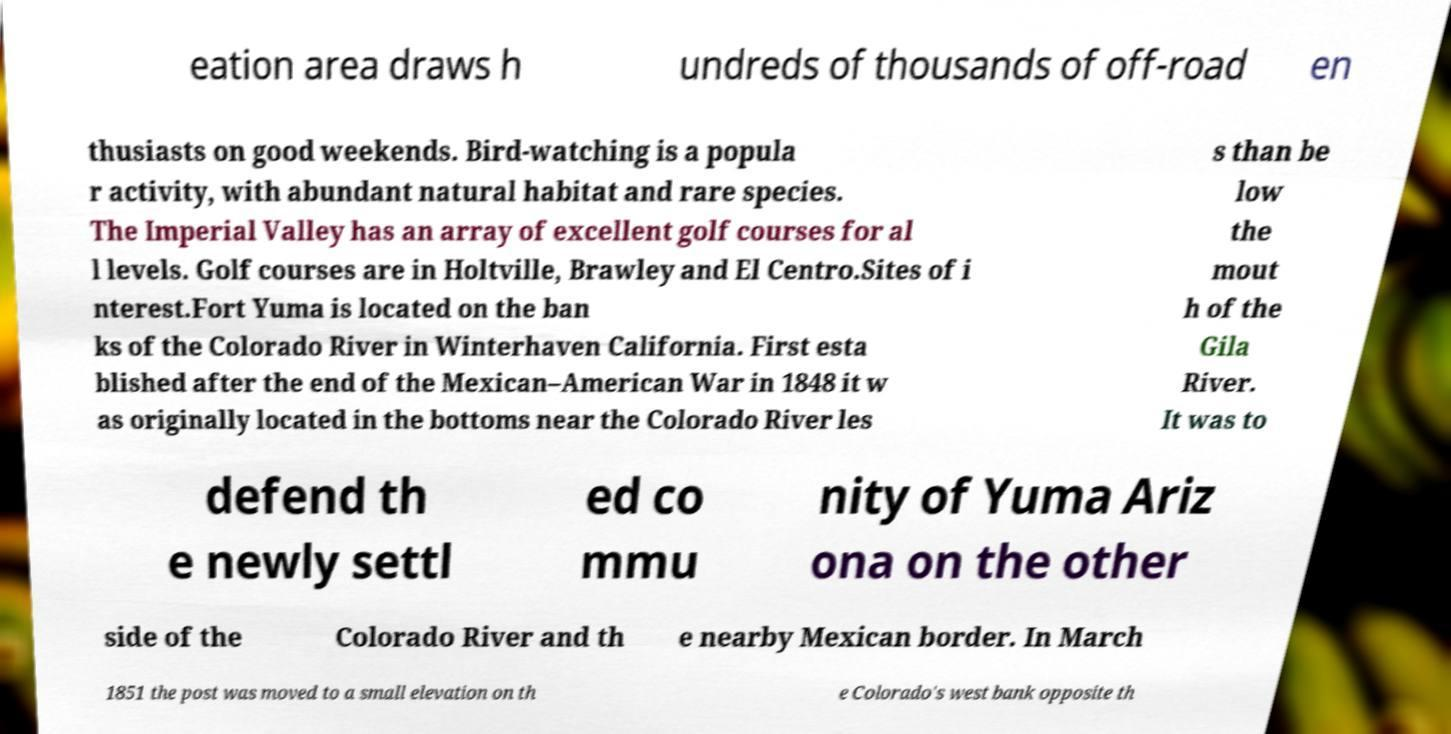Please read and relay the text visible in this image. What does it say? eation area draws h undreds of thousands of off-road en thusiasts on good weekends. Bird-watching is a popula r activity, with abundant natural habitat and rare species. The Imperial Valley has an array of excellent golf courses for al l levels. Golf courses are in Holtville, Brawley and El Centro.Sites of i nterest.Fort Yuma is located on the ban ks of the Colorado River in Winterhaven California. First esta blished after the end of the Mexican–American War in 1848 it w as originally located in the bottoms near the Colorado River les s than be low the mout h of the Gila River. It was to defend th e newly settl ed co mmu nity of Yuma Ariz ona on the other side of the Colorado River and th e nearby Mexican border. In March 1851 the post was moved to a small elevation on th e Colorado's west bank opposite th 